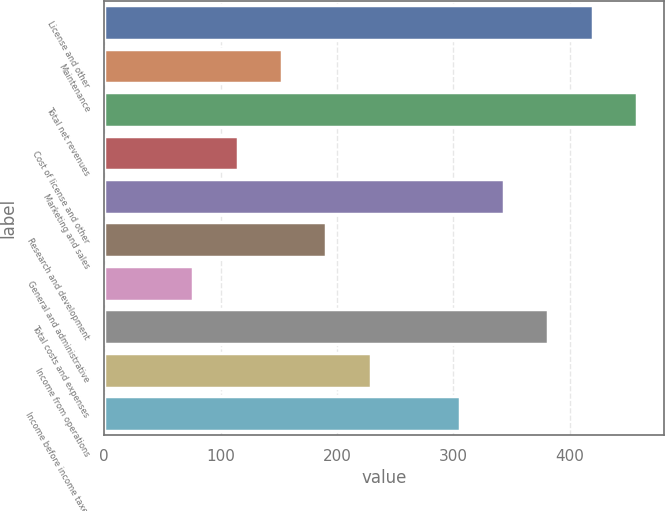Convert chart to OTSL. <chart><loc_0><loc_0><loc_500><loc_500><bar_chart><fcel>License and other<fcel>Maintenance<fcel>Total net revenues<fcel>Cost of license and other<fcel>Marketing and sales<fcel>Research and development<fcel>General and administrative<fcel>Total costs and expenses<fcel>Income from operations<fcel>Income before income taxes<nl><fcel>419.66<fcel>152.82<fcel>457.78<fcel>114.7<fcel>343.42<fcel>190.94<fcel>76.58<fcel>381.54<fcel>229.06<fcel>305.3<nl></chart> 